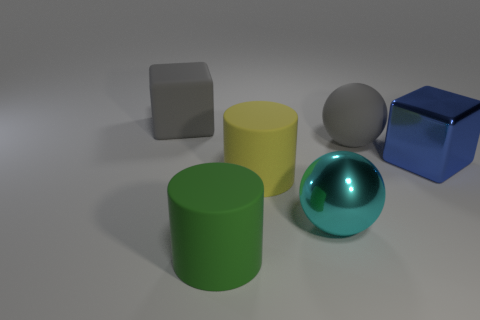Add 2 small rubber balls. How many objects exist? 8 Subtract all spheres. How many objects are left? 4 Add 6 big yellow objects. How many big yellow objects exist? 7 Subtract 0 blue cylinders. How many objects are left? 6 Subtract all big brown blocks. Subtract all large rubber objects. How many objects are left? 2 Add 1 yellow matte things. How many yellow matte things are left? 2 